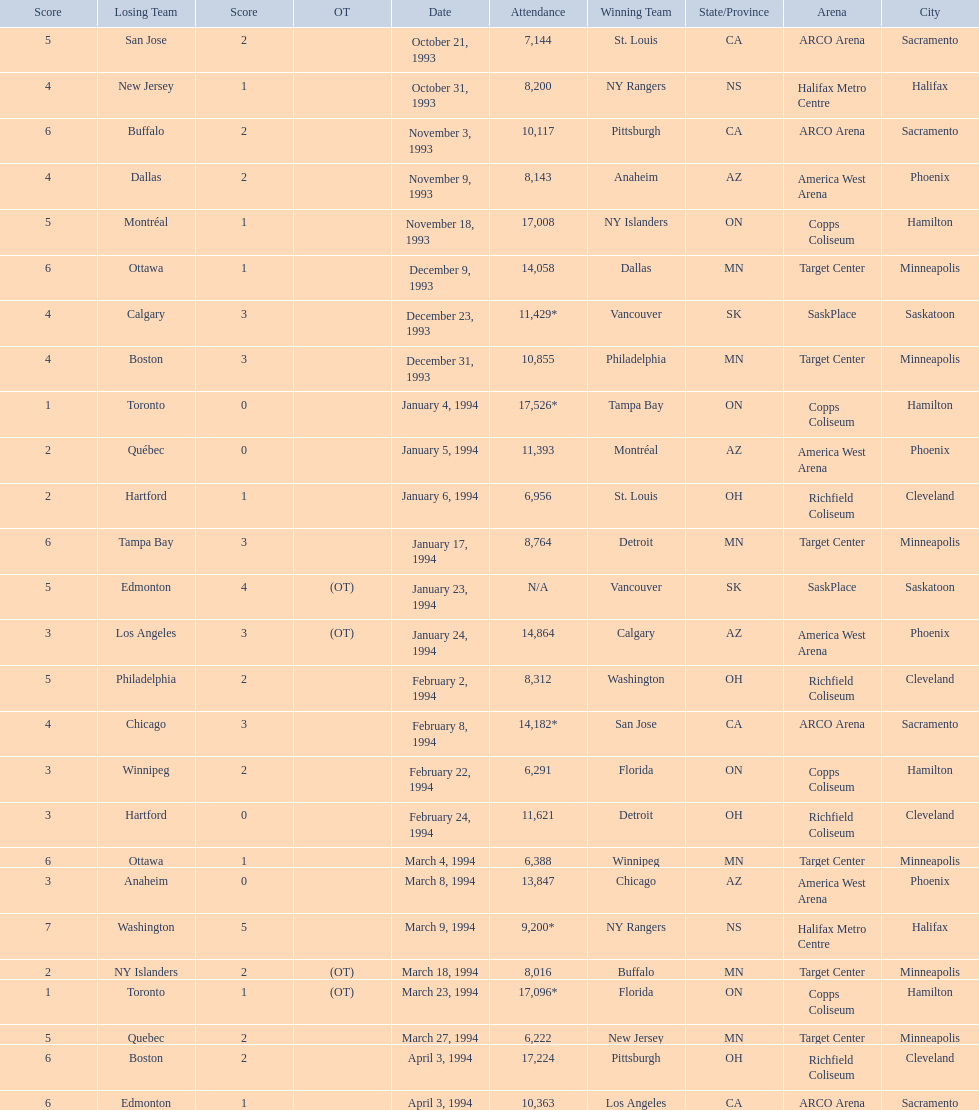What was the attendance on january 24, 1994? 14,864. What was the attendance on december 23, 1993? 11,429*. Between january 24, 1994 and december 23, 1993, which had the higher attendance? January 4, 1994. 